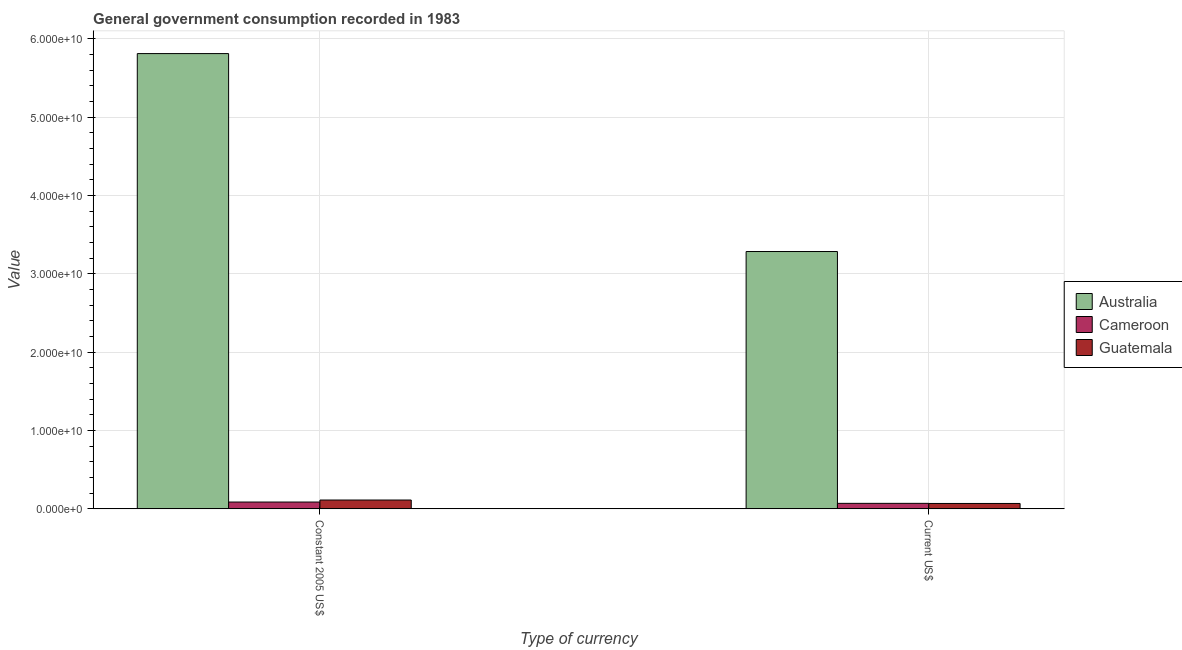How many different coloured bars are there?
Offer a terse response. 3. Are the number of bars per tick equal to the number of legend labels?
Ensure brevity in your answer.  Yes. Are the number of bars on each tick of the X-axis equal?
Keep it short and to the point. Yes. How many bars are there on the 1st tick from the right?
Make the answer very short. 3. What is the label of the 1st group of bars from the left?
Your answer should be very brief. Constant 2005 US$. What is the value consumed in constant 2005 us$ in Cameroon?
Ensure brevity in your answer.  8.69e+08. Across all countries, what is the maximum value consumed in current us$?
Your answer should be compact. 3.28e+1. Across all countries, what is the minimum value consumed in constant 2005 us$?
Your answer should be compact. 8.69e+08. In which country was the value consumed in current us$ minimum?
Keep it short and to the point. Guatemala. What is the total value consumed in current us$ in the graph?
Make the answer very short. 3.42e+1. What is the difference between the value consumed in constant 2005 us$ in Cameroon and that in Australia?
Give a very brief answer. -5.72e+1. What is the difference between the value consumed in constant 2005 us$ in Guatemala and the value consumed in current us$ in Australia?
Your response must be concise. -3.17e+1. What is the average value consumed in constant 2005 us$ per country?
Make the answer very short. 2.00e+1. What is the difference between the value consumed in current us$ and value consumed in constant 2005 us$ in Cameroon?
Make the answer very short. -1.68e+08. What is the ratio of the value consumed in current us$ in Guatemala to that in Cameroon?
Your answer should be very brief. 0.98. Is the value consumed in constant 2005 us$ in Guatemala less than that in Australia?
Ensure brevity in your answer.  Yes. What does the 3rd bar from the left in Current US$ represents?
Offer a terse response. Guatemala. What does the 2nd bar from the right in Constant 2005 US$ represents?
Provide a succinct answer. Cameroon. How many bars are there?
Make the answer very short. 6. Are all the bars in the graph horizontal?
Your answer should be very brief. No. How many countries are there in the graph?
Your answer should be very brief. 3. What is the difference between two consecutive major ticks on the Y-axis?
Provide a succinct answer. 1.00e+1. Does the graph contain any zero values?
Ensure brevity in your answer.  No. Does the graph contain grids?
Provide a succinct answer. Yes. How are the legend labels stacked?
Provide a succinct answer. Vertical. What is the title of the graph?
Offer a very short reply. General government consumption recorded in 1983. What is the label or title of the X-axis?
Offer a very short reply. Type of currency. What is the label or title of the Y-axis?
Provide a short and direct response. Value. What is the Value in Australia in Constant 2005 US$?
Make the answer very short. 5.81e+1. What is the Value of Cameroon in Constant 2005 US$?
Offer a very short reply. 8.69e+08. What is the Value in Guatemala in Constant 2005 US$?
Your answer should be very brief. 1.13e+09. What is the Value in Australia in Current US$?
Your answer should be very brief. 3.28e+1. What is the Value in Cameroon in Current US$?
Offer a terse response. 7.01e+08. What is the Value in Guatemala in Current US$?
Ensure brevity in your answer.  6.88e+08. Across all Type of currency, what is the maximum Value of Australia?
Provide a succinct answer. 5.81e+1. Across all Type of currency, what is the maximum Value in Cameroon?
Your answer should be compact. 8.69e+08. Across all Type of currency, what is the maximum Value of Guatemala?
Give a very brief answer. 1.13e+09. Across all Type of currency, what is the minimum Value in Australia?
Provide a short and direct response. 3.28e+1. Across all Type of currency, what is the minimum Value in Cameroon?
Your answer should be compact. 7.01e+08. Across all Type of currency, what is the minimum Value of Guatemala?
Your response must be concise. 6.88e+08. What is the total Value of Australia in the graph?
Provide a succinct answer. 9.09e+1. What is the total Value of Cameroon in the graph?
Ensure brevity in your answer.  1.57e+09. What is the total Value in Guatemala in the graph?
Your answer should be very brief. 1.81e+09. What is the difference between the Value in Australia in Constant 2005 US$ and that in Current US$?
Offer a very short reply. 2.53e+1. What is the difference between the Value in Cameroon in Constant 2005 US$ and that in Current US$?
Make the answer very short. 1.68e+08. What is the difference between the Value in Guatemala in Constant 2005 US$ and that in Current US$?
Offer a terse response. 4.37e+08. What is the difference between the Value of Australia in Constant 2005 US$ and the Value of Cameroon in Current US$?
Give a very brief answer. 5.74e+1. What is the difference between the Value in Australia in Constant 2005 US$ and the Value in Guatemala in Current US$?
Give a very brief answer. 5.74e+1. What is the difference between the Value of Cameroon in Constant 2005 US$ and the Value of Guatemala in Current US$?
Your answer should be compact. 1.81e+08. What is the average Value in Australia per Type of currency?
Make the answer very short. 4.55e+1. What is the average Value of Cameroon per Type of currency?
Offer a terse response. 7.85e+08. What is the average Value in Guatemala per Type of currency?
Your response must be concise. 9.07e+08. What is the difference between the Value in Australia and Value in Cameroon in Constant 2005 US$?
Provide a succinct answer. 5.72e+1. What is the difference between the Value in Australia and Value in Guatemala in Constant 2005 US$?
Your answer should be compact. 5.70e+1. What is the difference between the Value in Cameroon and Value in Guatemala in Constant 2005 US$?
Provide a short and direct response. -2.56e+08. What is the difference between the Value of Australia and Value of Cameroon in Current US$?
Your answer should be very brief. 3.21e+1. What is the difference between the Value in Australia and Value in Guatemala in Current US$?
Your response must be concise. 3.22e+1. What is the difference between the Value of Cameroon and Value of Guatemala in Current US$?
Your answer should be compact. 1.32e+07. What is the ratio of the Value of Australia in Constant 2005 US$ to that in Current US$?
Offer a terse response. 1.77. What is the ratio of the Value of Cameroon in Constant 2005 US$ to that in Current US$?
Your answer should be compact. 1.24. What is the ratio of the Value of Guatemala in Constant 2005 US$ to that in Current US$?
Make the answer very short. 1.64. What is the difference between the highest and the second highest Value of Australia?
Offer a terse response. 2.53e+1. What is the difference between the highest and the second highest Value of Cameroon?
Your answer should be very brief. 1.68e+08. What is the difference between the highest and the second highest Value of Guatemala?
Your answer should be very brief. 4.37e+08. What is the difference between the highest and the lowest Value of Australia?
Provide a short and direct response. 2.53e+1. What is the difference between the highest and the lowest Value in Cameroon?
Offer a very short reply. 1.68e+08. What is the difference between the highest and the lowest Value of Guatemala?
Offer a terse response. 4.37e+08. 